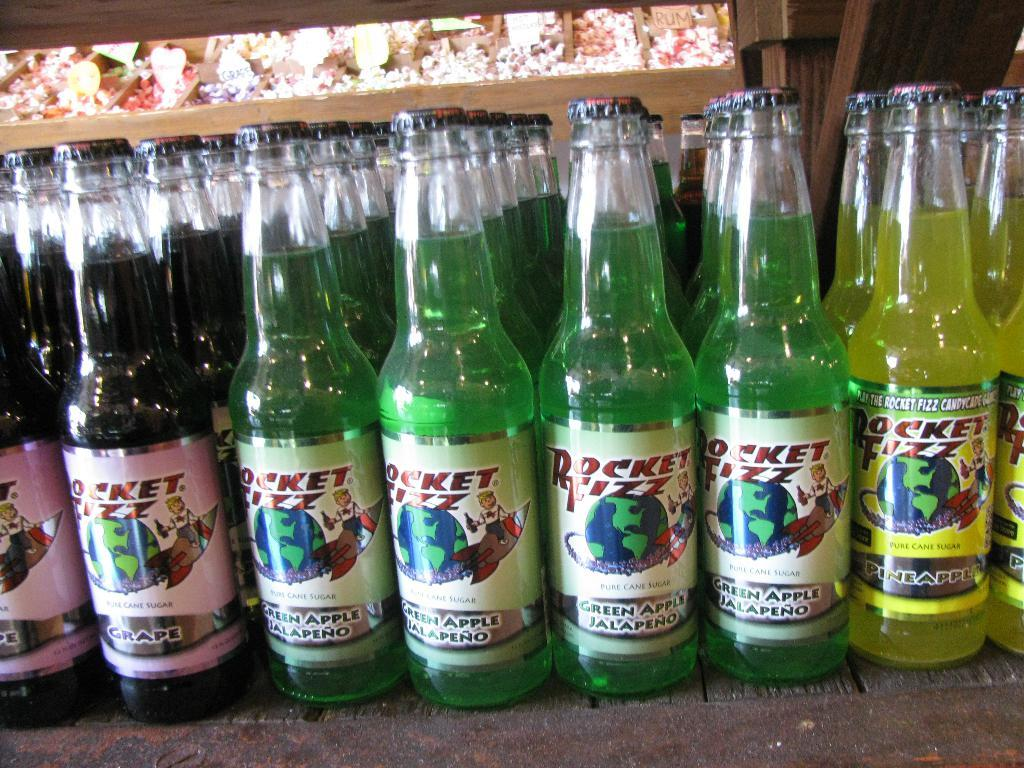<image>
Relay a brief, clear account of the picture shown. bottles standing next to one another that says 'rocket fizz' on them 